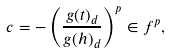Convert formula to latex. <formula><loc_0><loc_0><loc_500><loc_500>c = - \left ( \frac { g ( t ) _ { d } } { g ( h ) _ { d } } \right ) ^ { p } \in f ^ { p } ,</formula> 